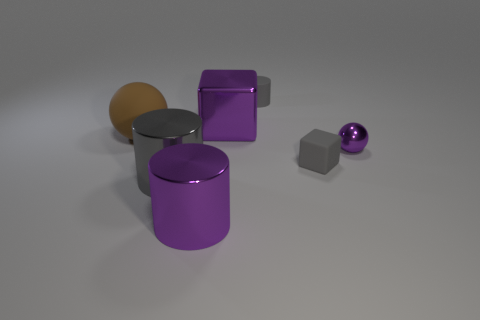There is a purple metallic thing in front of the large gray shiny thing; what size is it? The purple metallic thing appears to be a mid-sized cylindrical object relative to the objects around it—it is smaller than the large gray metallic cylinder nearby but bigger than the small purple sphere off to one side. 